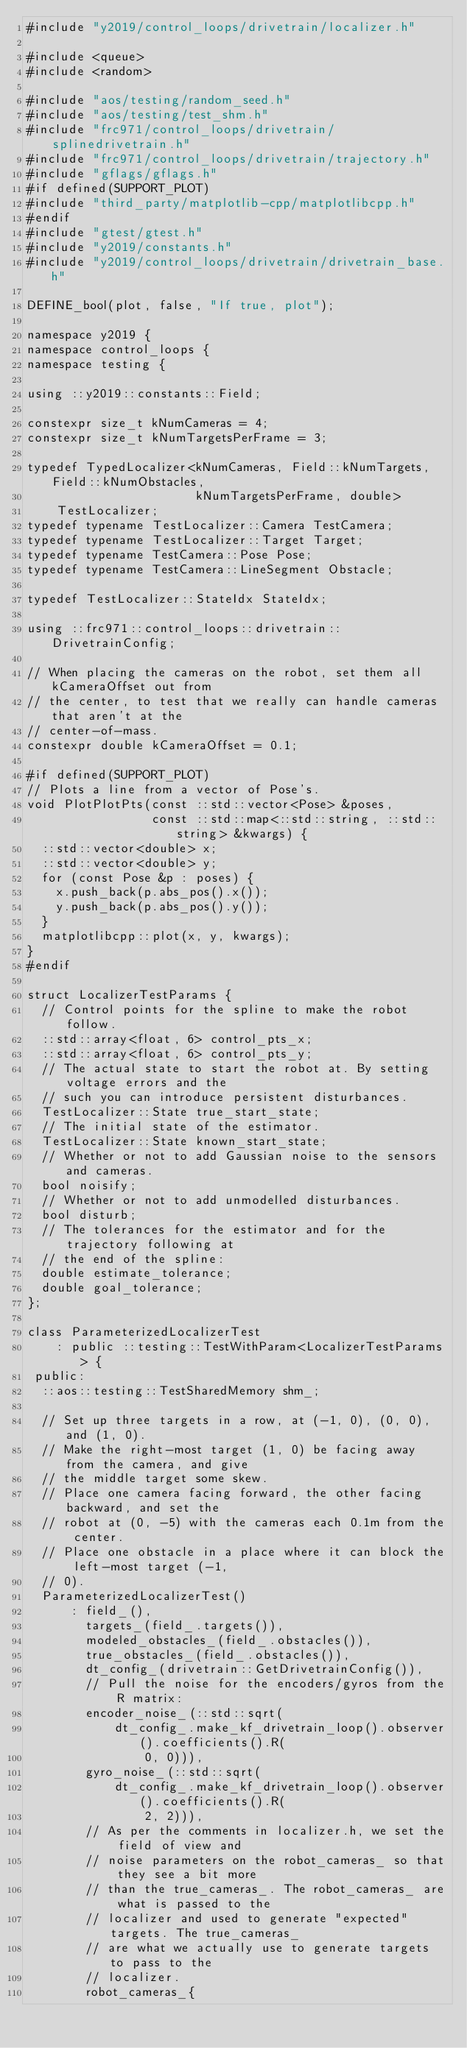Convert code to text. <code><loc_0><loc_0><loc_500><loc_500><_C++_>#include "y2019/control_loops/drivetrain/localizer.h"

#include <queue>
#include <random>

#include "aos/testing/random_seed.h"
#include "aos/testing/test_shm.h"
#include "frc971/control_loops/drivetrain/splinedrivetrain.h"
#include "frc971/control_loops/drivetrain/trajectory.h"
#include "gflags/gflags.h"
#if defined(SUPPORT_PLOT)
#include "third_party/matplotlib-cpp/matplotlibcpp.h"
#endif
#include "gtest/gtest.h"
#include "y2019/constants.h"
#include "y2019/control_loops/drivetrain/drivetrain_base.h"

DEFINE_bool(plot, false, "If true, plot");

namespace y2019 {
namespace control_loops {
namespace testing {

using ::y2019::constants::Field;

constexpr size_t kNumCameras = 4;
constexpr size_t kNumTargetsPerFrame = 3;

typedef TypedLocalizer<kNumCameras, Field::kNumTargets, Field::kNumObstacles,
                       kNumTargetsPerFrame, double>
    TestLocalizer;
typedef typename TestLocalizer::Camera TestCamera;
typedef typename TestLocalizer::Target Target;
typedef typename TestCamera::Pose Pose;
typedef typename TestCamera::LineSegment Obstacle;

typedef TestLocalizer::StateIdx StateIdx;

using ::frc971::control_loops::drivetrain::DrivetrainConfig;

// When placing the cameras on the robot, set them all kCameraOffset out from
// the center, to test that we really can handle cameras that aren't at the
// center-of-mass.
constexpr double kCameraOffset = 0.1;

#if defined(SUPPORT_PLOT)
// Plots a line from a vector of Pose's.
void PlotPlotPts(const ::std::vector<Pose> &poses,
                 const ::std::map<::std::string, ::std::string> &kwargs) {
  ::std::vector<double> x;
  ::std::vector<double> y;
  for (const Pose &p : poses) {
    x.push_back(p.abs_pos().x());
    y.push_back(p.abs_pos().y());
  }
  matplotlibcpp::plot(x, y, kwargs);
}
#endif

struct LocalizerTestParams {
  // Control points for the spline to make the robot follow.
  ::std::array<float, 6> control_pts_x;
  ::std::array<float, 6> control_pts_y;
  // The actual state to start the robot at. By setting voltage errors and the
  // such you can introduce persistent disturbances.
  TestLocalizer::State true_start_state;
  // The initial state of the estimator.
  TestLocalizer::State known_start_state;
  // Whether or not to add Gaussian noise to the sensors and cameras.
  bool noisify;
  // Whether or not to add unmodelled disturbances.
  bool disturb;
  // The tolerances for the estimator and for the trajectory following at
  // the end of the spline:
  double estimate_tolerance;
  double goal_tolerance;
};

class ParameterizedLocalizerTest
    : public ::testing::TestWithParam<LocalizerTestParams> {
 public:
  ::aos::testing::TestSharedMemory shm_;

  // Set up three targets in a row, at (-1, 0), (0, 0), and (1, 0).
  // Make the right-most target (1, 0) be facing away from the camera, and give
  // the middle target some skew.
  // Place one camera facing forward, the other facing backward, and set the
  // robot at (0, -5) with the cameras each 0.1m from the center.
  // Place one obstacle in a place where it can block the left-most target (-1,
  // 0).
  ParameterizedLocalizerTest()
      : field_(),
        targets_(field_.targets()),
        modeled_obstacles_(field_.obstacles()),
        true_obstacles_(field_.obstacles()),
        dt_config_(drivetrain::GetDrivetrainConfig()),
        // Pull the noise for the encoders/gyros from the R matrix:
        encoder_noise_(::std::sqrt(
            dt_config_.make_kf_drivetrain_loop().observer().coefficients().R(
                0, 0))),
        gyro_noise_(::std::sqrt(
            dt_config_.make_kf_drivetrain_loop().observer().coefficients().R(
                2, 2))),
        // As per the comments in localizer.h, we set the field of view and
        // noise parameters on the robot_cameras_ so that they see a bit more
        // than the true_cameras_. The robot_cameras_ are what is passed to the
        // localizer and used to generate "expected" targets. The true_cameras_
        // are what we actually use to generate targets to pass to the
        // localizer.
        robot_cameras_{</code> 